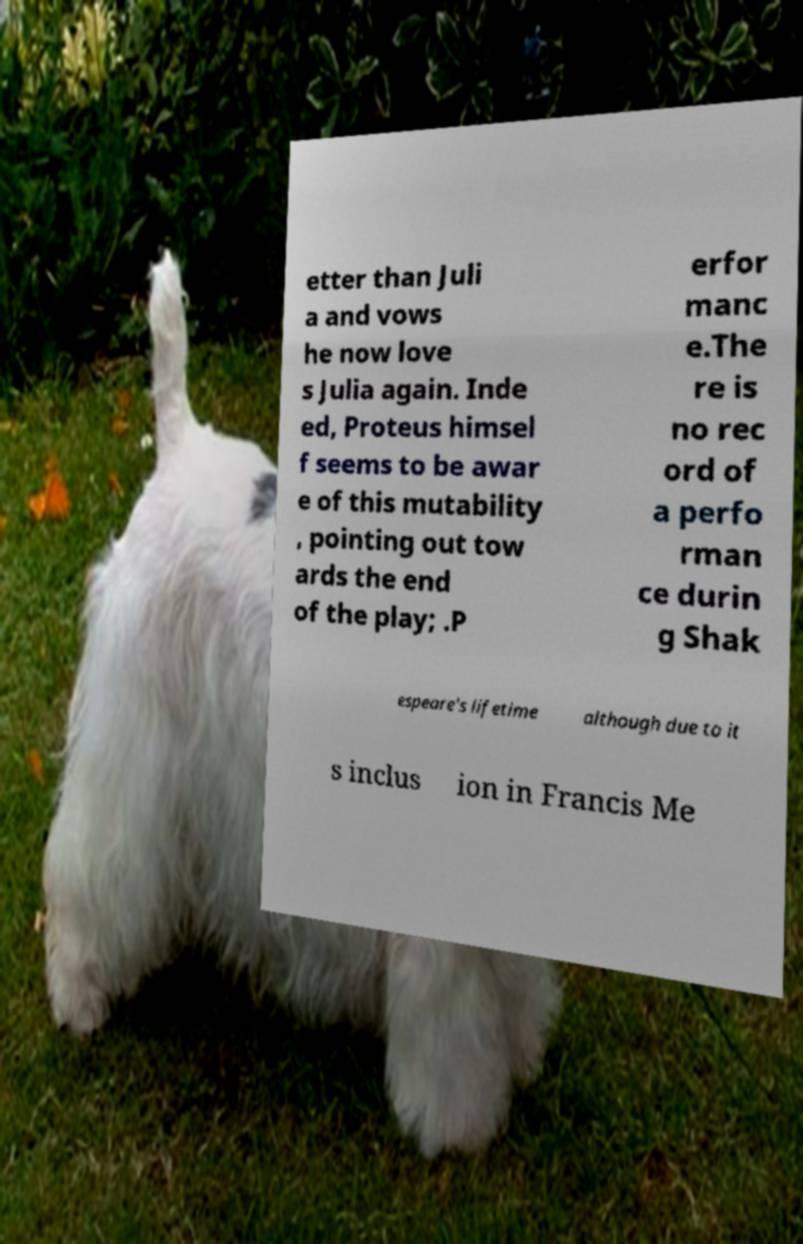Could you assist in decoding the text presented in this image and type it out clearly? etter than Juli a and vows he now love s Julia again. Inde ed, Proteus himsel f seems to be awar e of this mutability , pointing out tow ards the end of the play; .P erfor manc e.The re is no rec ord of a perfo rman ce durin g Shak espeare's lifetime although due to it s inclus ion in Francis Me 